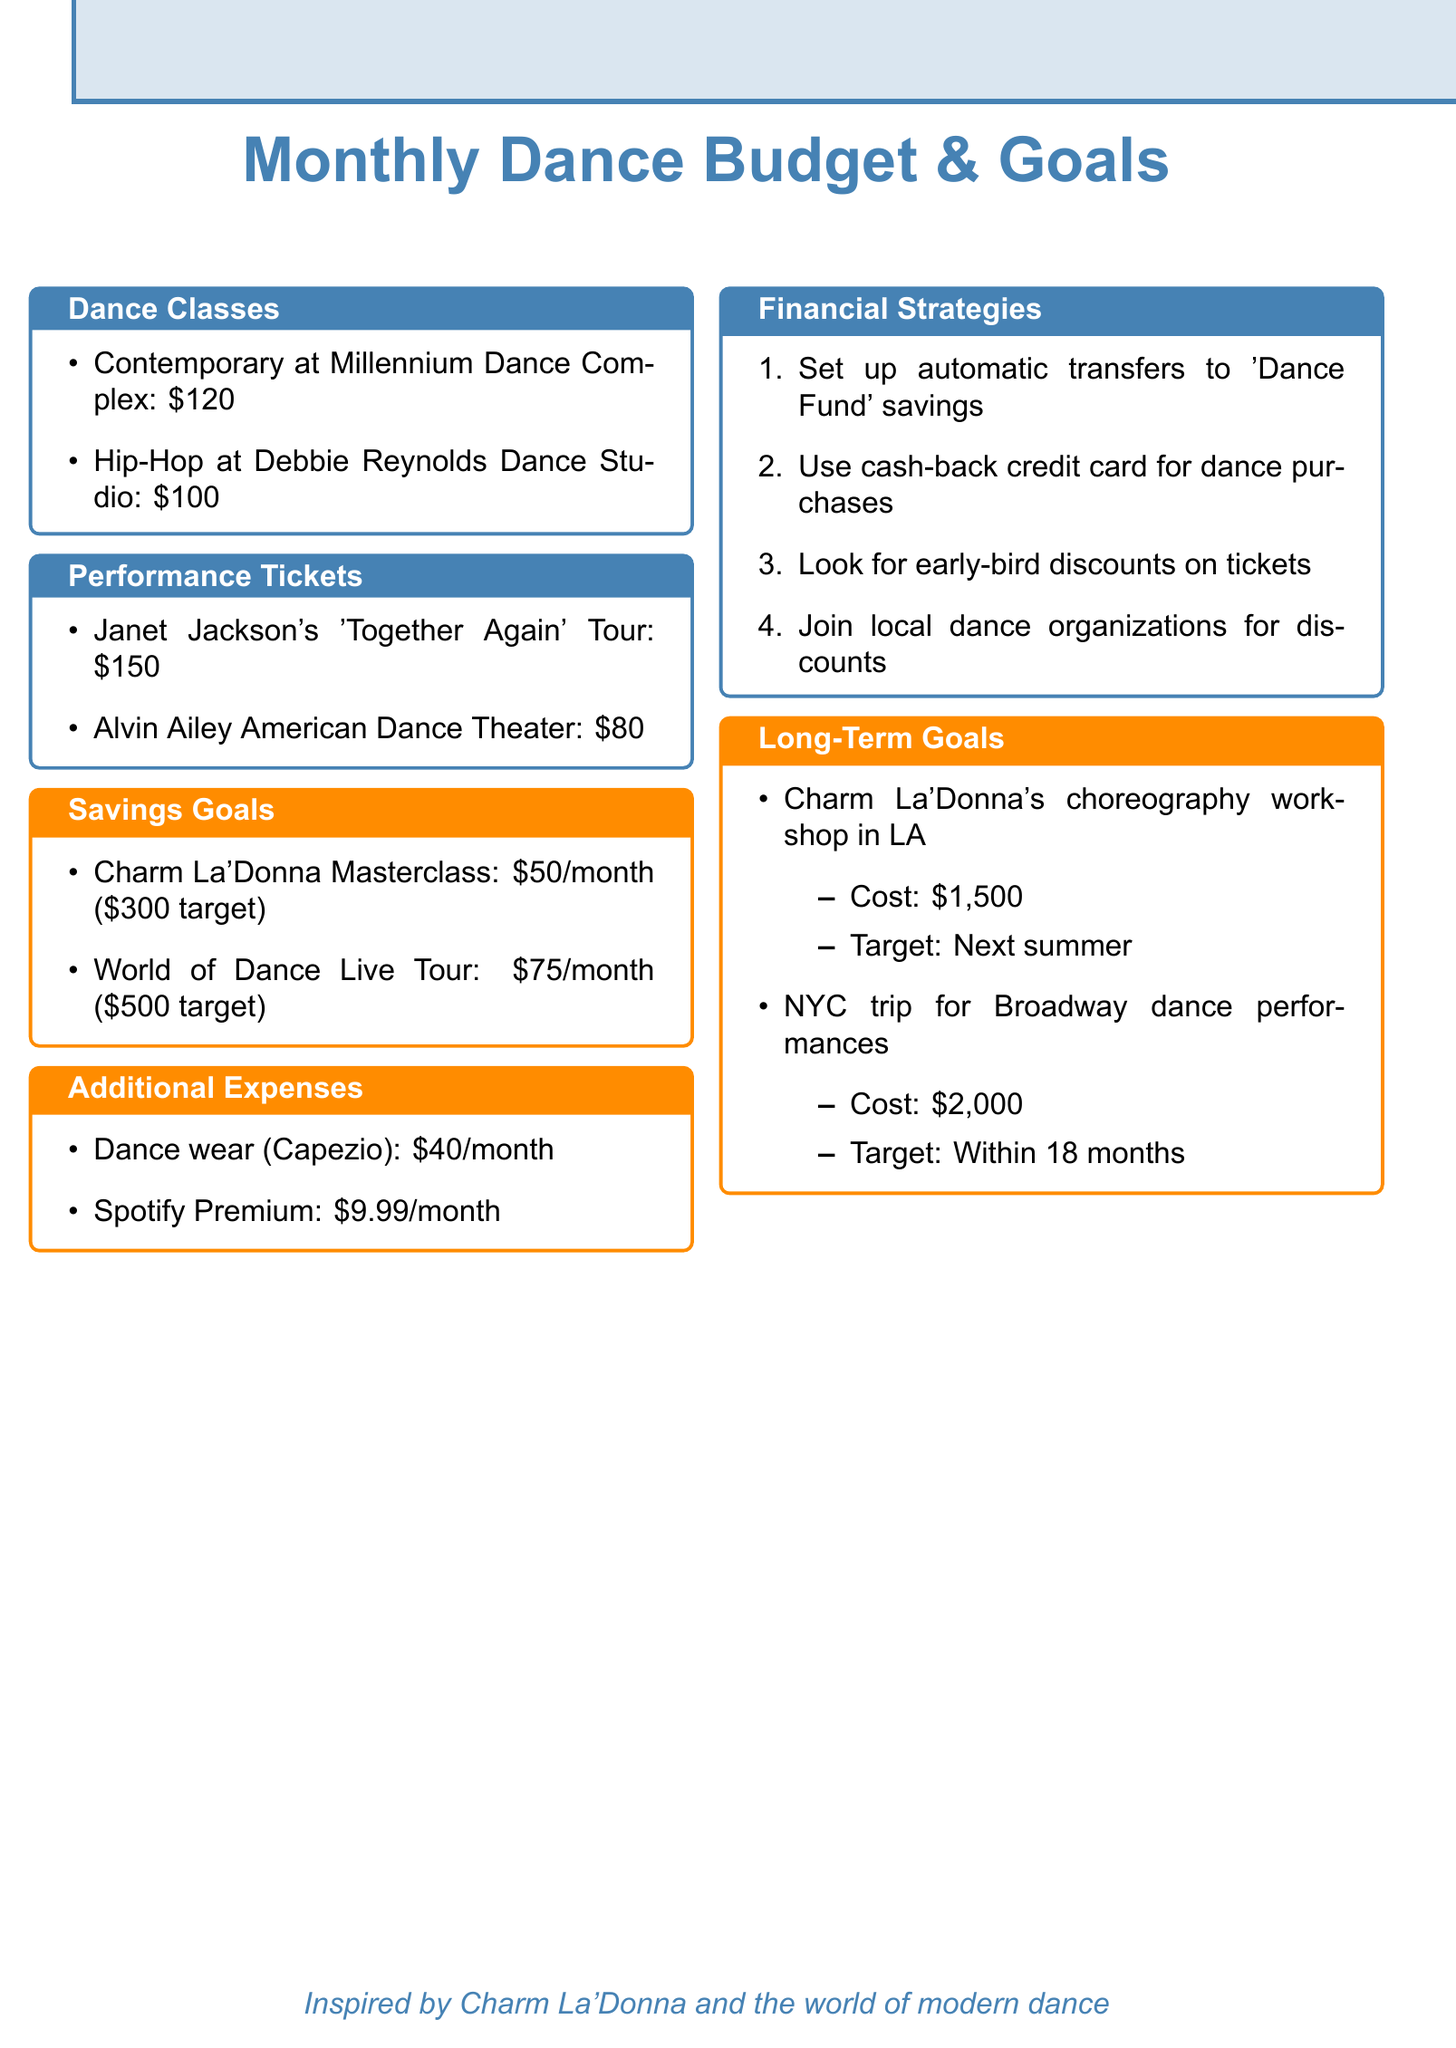What is the cost of Contemporary dance classes? The document states that Contemporary classes at Millennium Dance Complex cost $120.
Answer: $120 How much is allocated for the Alvin Ailey American Dance Theater tickets? According to the document, the allocation for Alvin Ailey American Dance Theater tickets is $80.
Answer: $80 What is the monthly savings goal for the Charm La'Donna Masterclass? The document specifies that the monthly savings goal for the Charm La'Donna Masterclass is $50.
Answer: $50 What is the total estimated cost for attending Charm La'Donna's workshop? The document indicates that the total estimated cost for attending Charm La'Donna's workshop is $1,500.
Answer: $1,500 How much is budgeted for music streaming? The document states that the monthly cost for Spotify Premium is $9.99.
Answer: $9.99 What is the total amount allocated for dance classes in the monthly budget? The sum of the dance classes costs is $120 (Contemporary) + $100 (Hip-Hop) = $220.
Answer: $220 How many events are listed under performance tickets? The document includes two events listed under performance tickets.
Answer: 2 What is one recommended financial strategy for saving? The document mentions several strategies; one is setting up automatic transfers to a 'Dance Fund' savings account.
Answer: Automatic transfers to a 'Dance Fund' What is the monthly allocation for dance wear? The document specifies that the monthly allocation for dance wear at Capezio is $40.
Answer: $40 When is the target date for the NYC trip for Broadway performances? The document states that the target date for the NYC trip is within 18 months.
Answer: Within 18 months 